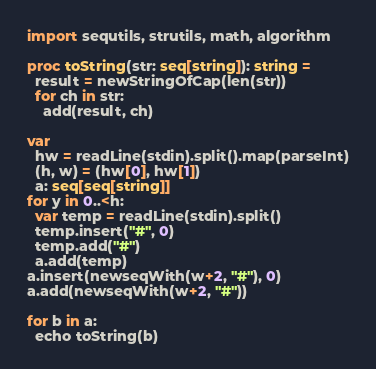Convert code to text. <code><loc_0><loc_0><loc_500><loc_500><_Nim_>import sequtils, strutils, math, algorithm

proc toString(str: seq[string]): string =
  result = newStringOfCap(len(str))
  for ch in str:
    add(result, ch)

var
  hw = readLine(stdin).split().map(parseInt)
  (h, w) = (hw[0], hw[1])
  a: seq[seq[string]]
for y in 0..<h:
  var temp = readLine(stdin).split()
  temp.insert("#", 0)
  temp.add("#")
  a.add(temp)
a.insert(newseqWith(w+2, "#"), 0)
a.add(newseqWith(w+2, "#"))

for b in a:
  echo toString(b)
</code> 